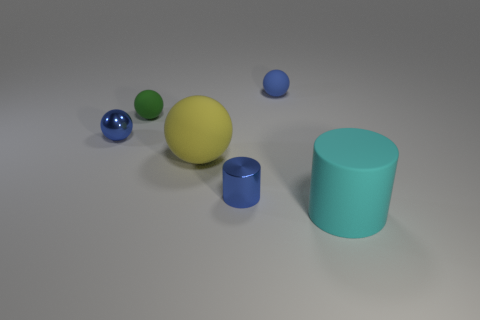Subtract all blue cylinders. How many blue balls are left? 2 Subtract all green spheres. How many spheres are left? 3 Subtract all small balls. How many balls are left? 1 Add 2 rubber balls. How many objects exist? 8 Subtract all yellow balls. Subtract all gray blocks. How many balls are left? 3 Subtract all spheres. How many objects are left? 2 Subtract 1 green balls. How many objects are left? 5 Subtract all green rubber spheres. Subtract all green matte things. How many objects are left? 4 Add 1 cyan rubber cylinders. How many cyan rubber cylinders are left? 2 Add 6 small green balls. How many small green balls exist? 7 